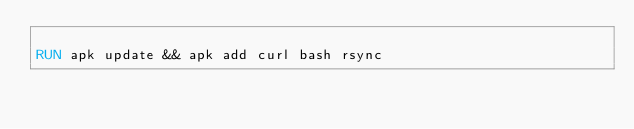Convert code to text. <code><loc_0><loc_0><loc_500><loc_500><_Dockerfile_>
RUN apk update && apk add curl bash rsync</code> 